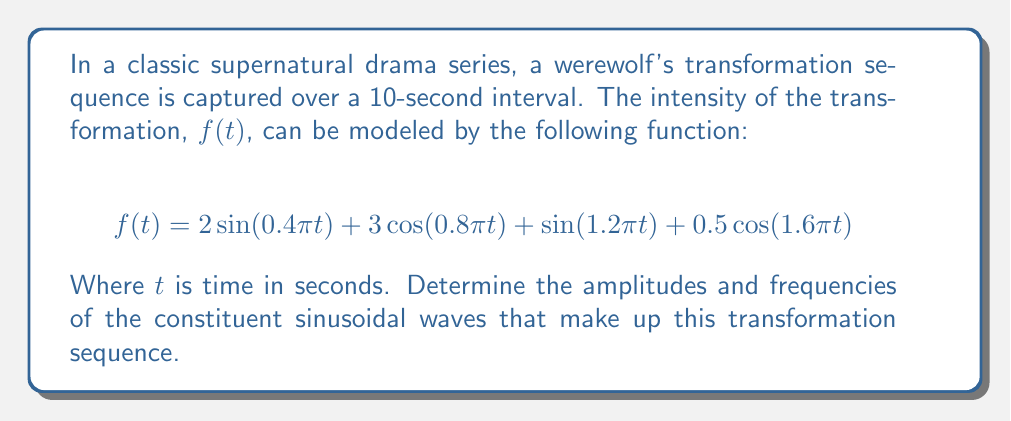Give your solution to this math problem. To decompose the werewolf's transformation sequence into its constituent sinusoidal waves, we need to identify the amplitudes and frequencies of each term in the given function. Let's break it down step by step:

1) The general form of a sinusoidal wave is $A\sin(2\pi ft)$ or $A\cos(2\pi ft)$, where $A$ is the amplitude and $f$ is the frequency in Hz.

2) Let's examine each term:

   a) $2\sin(0.4\pi t)$:
      Amplitude $A_1 = 2$
      Angular frequency $\omega_1 = 0.4\pi$
      Frequency $f_1 = \frac{\omega_1}{2\pi} = 0.2$ Hz

   b) $3\cos(0.8\pi t)$:
      Amplitude $A_2 = 3$
      Angular frequency $\omega_2 = 0.8\pi$
      Frequency $f_2 = \frac{\omega_2}{2\pi} = 0.4$ Hz

   c) $\sin(1.2\pi t)$:
      Amplitude $A_3 = 1$
      Angular frequency $\omega_3 = 1.2\pi$
      Frequency $f_3 = \frac{\omega_3}{2\pi} = 0.6$ Hz

   d) $0.5\cos(1.6\pi t)$:
      Amplitude $A_4 = 0.5$
      Angular frequency $\omega_4 = 1.6\pi$
      Frequency $f_4 = \frac{\omega_4}{2\pi} = 0.8$ Hz

3) Each of these terms represents a sinusoidal wave that contributes to the overall transformation sequence.
Answer: The werewolf's transformation sequence consists of four sinusoidal waves:

1) Amplitude $2$, Frequency $0.2$ Hz
2) Amplitude $3$, Frequency $0.4$ Hz
3) Amplitude $1$, Frequency $0.6$ Hz
4) Amplitude $0.5$, Frequency $0.8$ Hz 